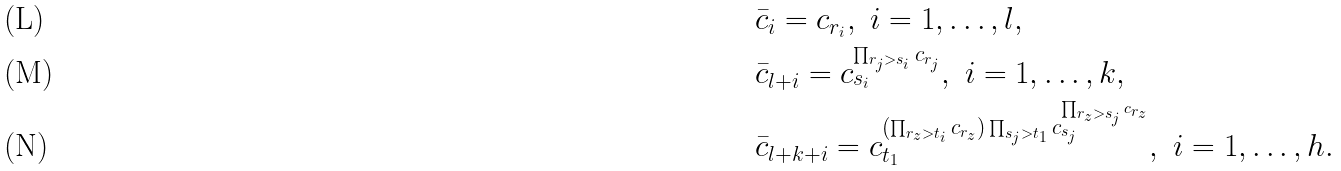<formula> <loc_0><loc_0><loc_500><loc_500>& \bar { c } _ { i } = c _ { r _ { i } } , \ i = 1 , \dots , l , \\ & \bar { c } _ { l + i } = c _ { s _ { i } } ^ { \prod _ { r _ { j } > s _ { i } } c _ { r _ { j } } } , \ i = 1 , \dots , k , \\ & \bar { c } _ { l + k + i } = c _ { t _ { 1 } } ^ { ( \prod _ { r _ { z } > t _ { i } } c _ { r _ { z } } ) \prod _ { s _ { j } > t _ { 1 } } c _ { s _ { j } } ^ { \prod _ { r _ { z } > s _ { j } } c _ { r _ { z } } } } , \ i = 1 , \dots , h .</formula> 